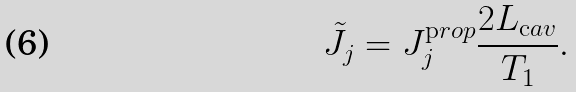Convert formula to latex. <formula><loc_0><loc_0><loc_500><loc_500>\tilde { J } _ { j } = J _ { j } ^ { \mathrm p r o p } \frac { 2 L _ { \mathrm c a v } } { T _ { 1 } } .</formula> 